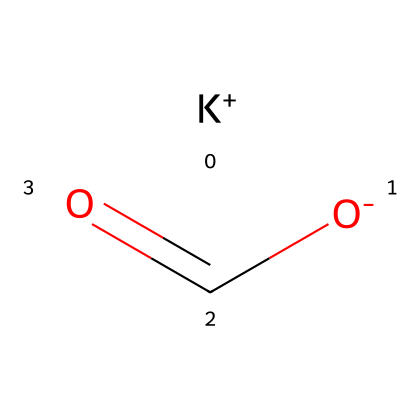What is the molecular formula of potassium formate? The SMILES representation shows a combination of potassium (K) and formate (HCOO) ions. Together, they form the compound potassium formate, represented by the molecular formula KC1H1O2.
Answer: KC1H1O2 How many oxygen atoms are present in potassium formate? In the structure, the formate ion contains two oxygen atoms bonded to the carbon atom. The potassium does not contribute additional oxygen. Thus, there are a total of two oxygen atoms in the molecule.
Answer: 2 What type of compound is potassium formate classified as? Potassium formate is classified as a salt, specifically an electrolyte, since it consists of a cation (K+) and an anion (HCOO−). This classification is derived from its dissociation into ions in solution.
Answer: salt What is the charge of the potassium ion in this compound? The potassium ion, represented as K+ in the SMILES notation, indicates that it has a single positive charge. This is consistent with potassium's behavior as a typical alkali metal in ionic compounds.
Answer: +1 How does potassium formate dissociate in aqueous solution? In aqueous solution, potassium formate dissociates into potassium ions (K+) and formate ions (HCOO−). The K+ cation and HCOO− anion are separated and surrounded by water molecules, thus facilitating conductivity.
Answer: K+, HCOO− What properties of potassium formate make it suitable for low-temperature heat transfer fluids? Potassium formate has a low freezing point and possesses good thermal conductivity, allowing it to remain liquid and effective for heat transfer in low temperatures. Additionally, being an electrolyte enhances its heat transfer capabilities.
Answer: low freezing point, good thermal conductivity 